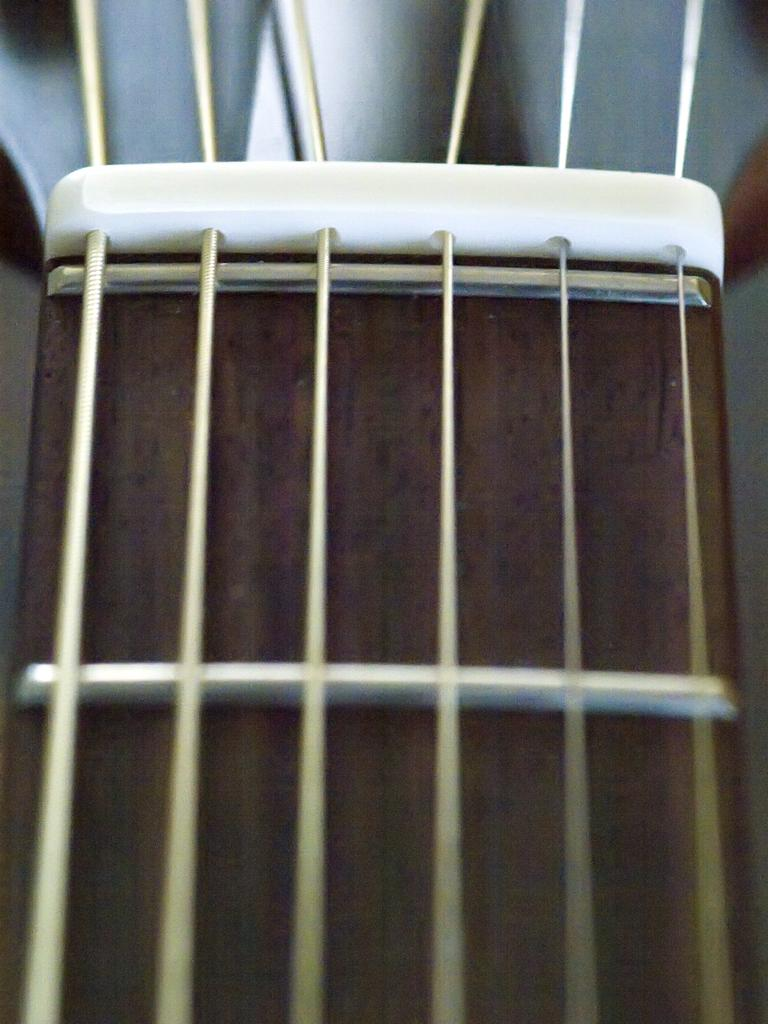What musical instrument is present in the image? There is a guitar in the image. How many strings does the guitar have? The guitar has many strings. What type of sponge is being used to clean the guitar in the image? There is no sponge present in the image, nor is there any indication of the guitar being cleaned. 